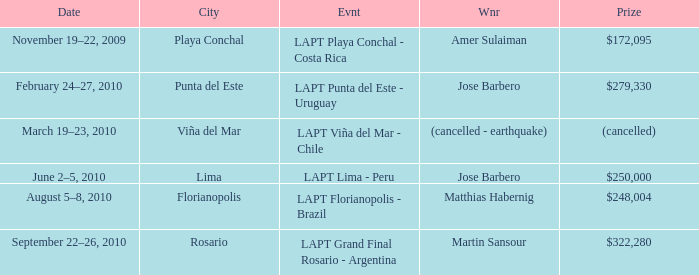Who is the winner in the city of lima? Jose Barbero. 